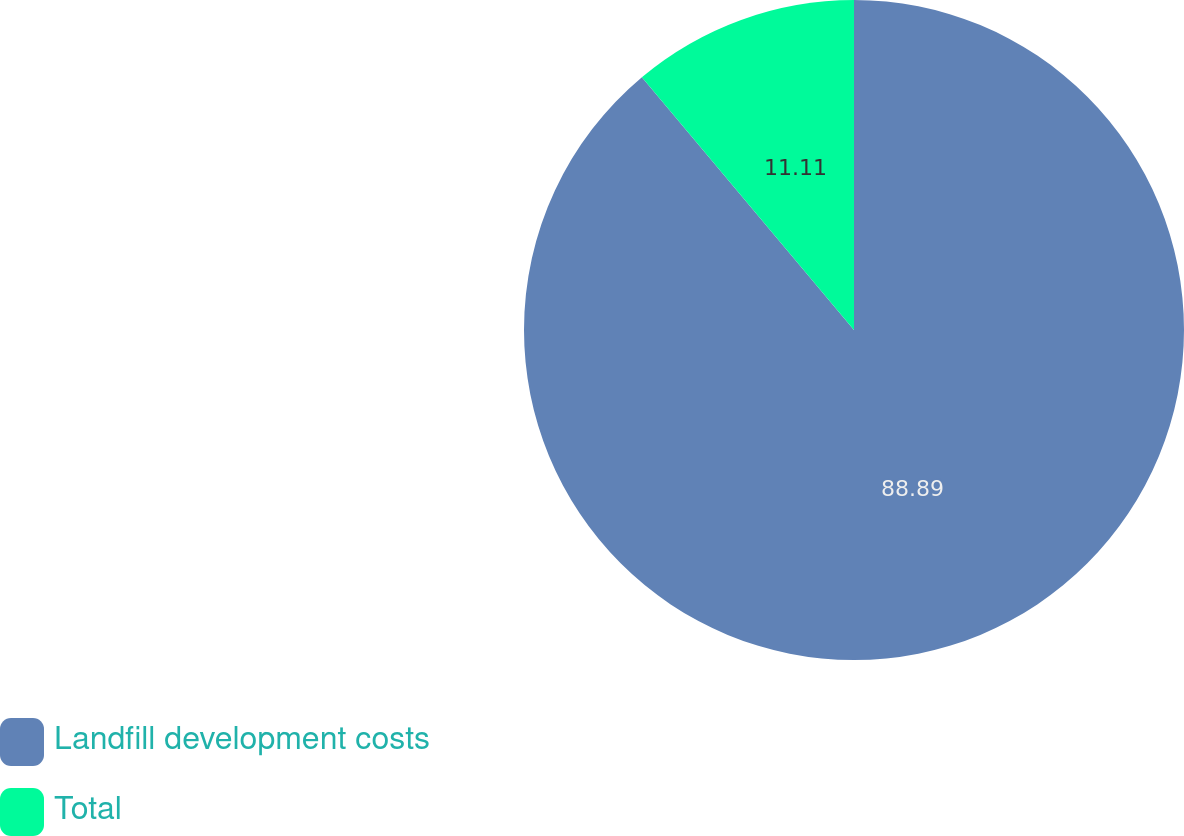Convert chart. <chart><loc_0><loc_0><loc_500><loc_500><pie_chart><fcel>Landfill development costs<fcel>Total<nl><fcel>88.89%<fcel>11.11%<nl></chart> 